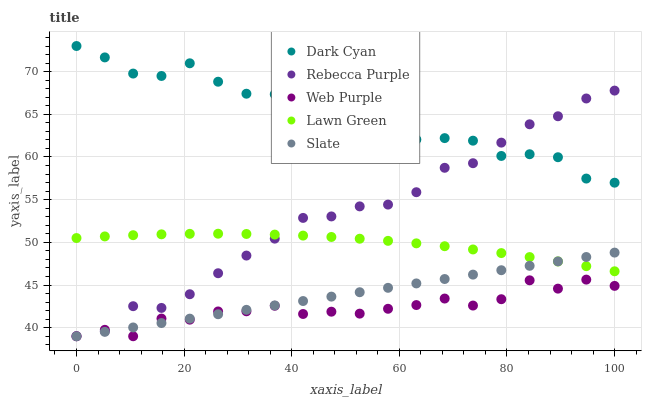Does Web Purple have the minimum area under the curve?
Answer yes or no. Yes. Does Dark Cyan have the maximum area under the curve?
Answer yes or no. Yes. Does Lawn Green have the minimum area under the curve?
Answer yes or no. No. Does Lawn Green have the maximum area under the curve?
Answer yes or no. No. Is Slate the smoothest?
Answer yes or no. Yes. Is Dark Cyan the roughest?
Answer yes or no. Yes. Is Lawn Green the smoothest?
Answer yes or no. No. Is Lawn Green the roughest?
Answer yes or no. No. Does Web Purple have the lowest value?
Answer yes or no. Yes. Does Lawn Green have the lowest value?
Answer yes or no. No. Does Dark Cyan have the highest value?
Answer yes or no. Yes. Does Lawn Green have the highest value?
Answer yes or no. No. Is Web Purple less than Dark Cyan?
Answer yes or no. Yes. Is Dark Cyan greater than Slate?
Answer yes or no. Yes. Does Rebecca Purple intersect Lawn Green?
Answer yes or no. Yes. Is Rebecca Purple less than Lawn Green?
Answer yes or no. No. Is Rebecca Purple greater than Lawn Green?
Answer yes or no. No. Does Web Purple intersect Dark Cyan?
Answer yes or no. No. 